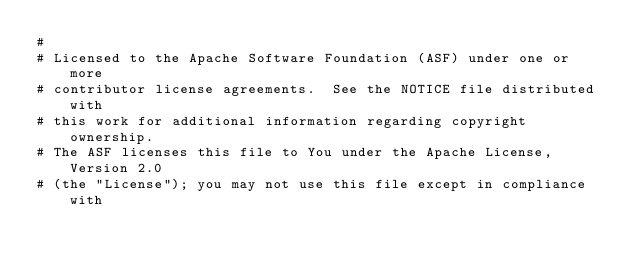Convert code to text. <code><loc_0><loc_0><loc_500><loc_500><_Python_>#
# Licensed to the Apache Software Foundation (ASF) under one or more
# contributor license agreements.  See the NOTICE file distributed with
# this work for additional information regarding copyright ownership.
# The ASF licenses this file to You under the Apache License, Version 2.0
# (the "License"); you may not use this file except in compliance with</code> 